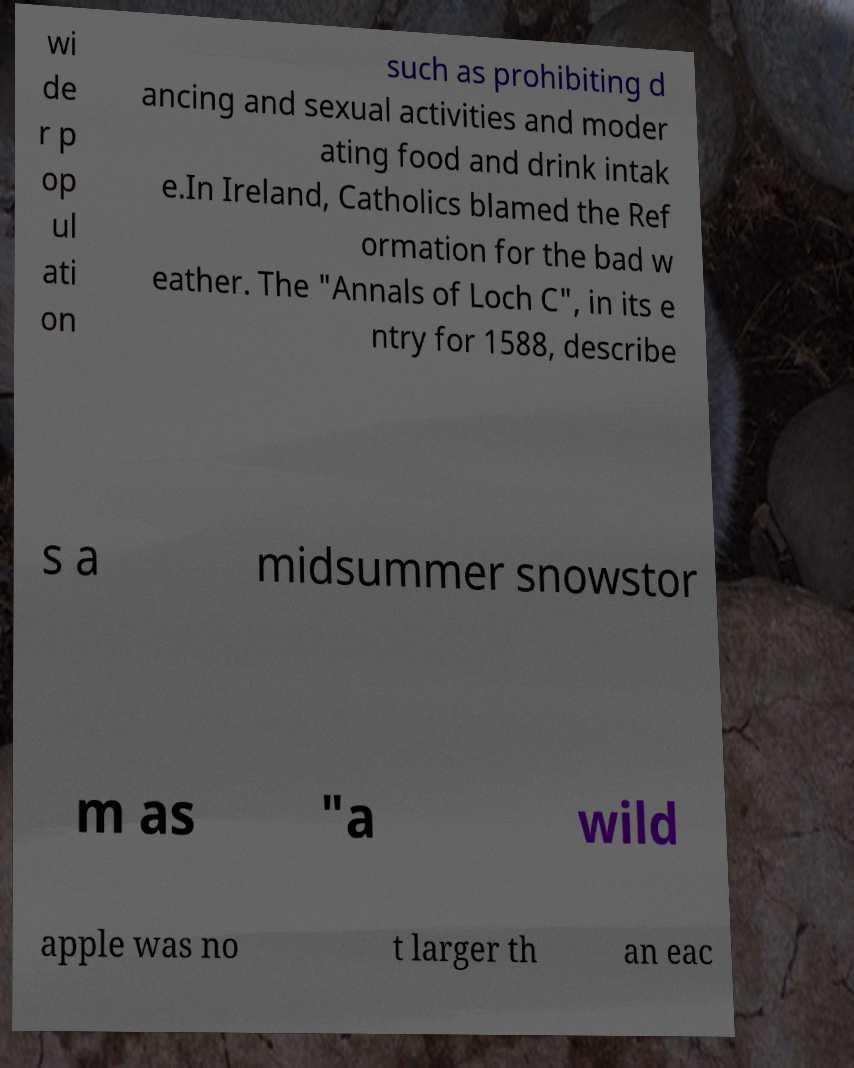Please identify and transcribe the text found in this image. wi de r p op ul ati on such as prohibiting d ancing and sexual activities and moder ating food and drink intak e.In Ireland, Catholics blamed the Ref ormation for the bad w eather. The "Annals of Loch C", in its e ntry for 1588, describe s a midsummer snowstor m as "a wild apple was no t larger th an eac 